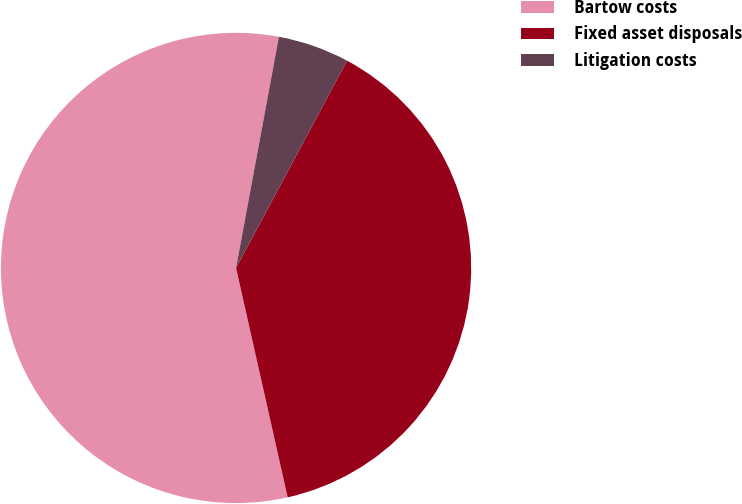Convert chart. <chart><loc_0><loc_0><loc_500><loc_500><pie_chart><fcel>Bartow costs<fcel>Fixed asset disposals<fcel>Litigation costs<nl><fcel>56.44%<fcel>38.65%<fcel>4.91%<nl></chart> 